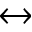Convert formula to latex. <formula><loc_0><loc_0><loc_500><loc_500>\leftrightarrow</formula> 